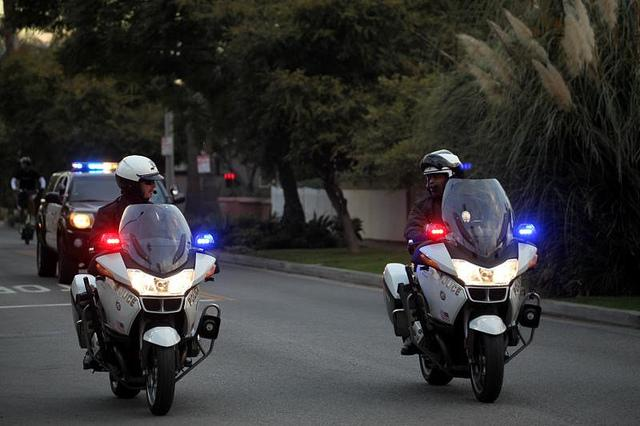What color is the officer riding on the police motorcycle to the left? white 